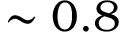Convert formula to latex. <formula><loc_0><loc_0><loc_500><loc_500>\sim 0 . 8</formula> 